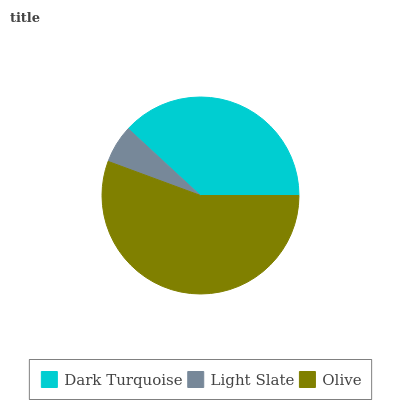Is Light Slate the minimum?
Answer yes or no. Yes. Is Olive the maximum?
Answer yes or no. Yes. Is Olive the minimum?
Answer yes or no. No. Is Light Slate the maximum?
Answer yes or no. No. Is Olive greater than Light Slate?
Answer yes or no. Yes. Is Light Slate less than Olive?
Answer yes or no. Yes. Is Light Slate greater than Olive?
Answer yes or no. No. Is Olive less than Light Slate?
Answer yes or no. No. Is Dark Turquoise the high median?
Answer yes or no. Yes. Is Dark Turquoise the low median?
Answer yes or no. Yes. Is Olive the high median?
Answer yes or no. No. Is Olive the low median?
Answer yes or no. No. 